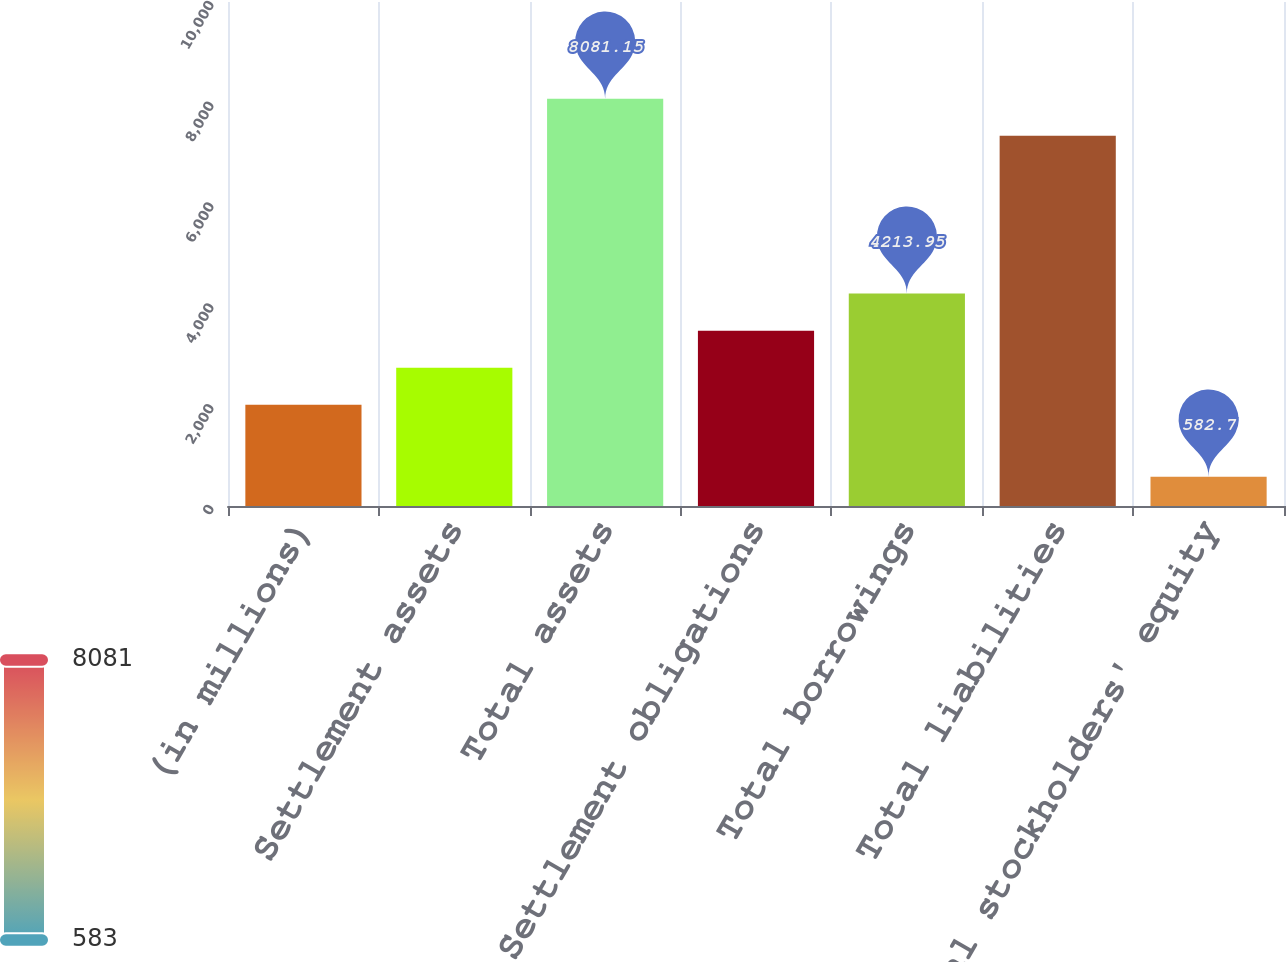Convert chart. <chart><loc_0><loc_0><loc_500><loc_500><bar_chart><fcel>(in millions)<fcel>Settlement assets<fcel>Total assets<fcel>Settlement obligations<fcel>Total borrowings<fcel>Total liabilities<fcel>Total stockholders' equity<nl><fcel>2010<fcel>2744.65<fcel>8081.15<fcel>3479.3<fcel>4213.95<fcel>7346.5<fcel>582.7<nl></chart> 